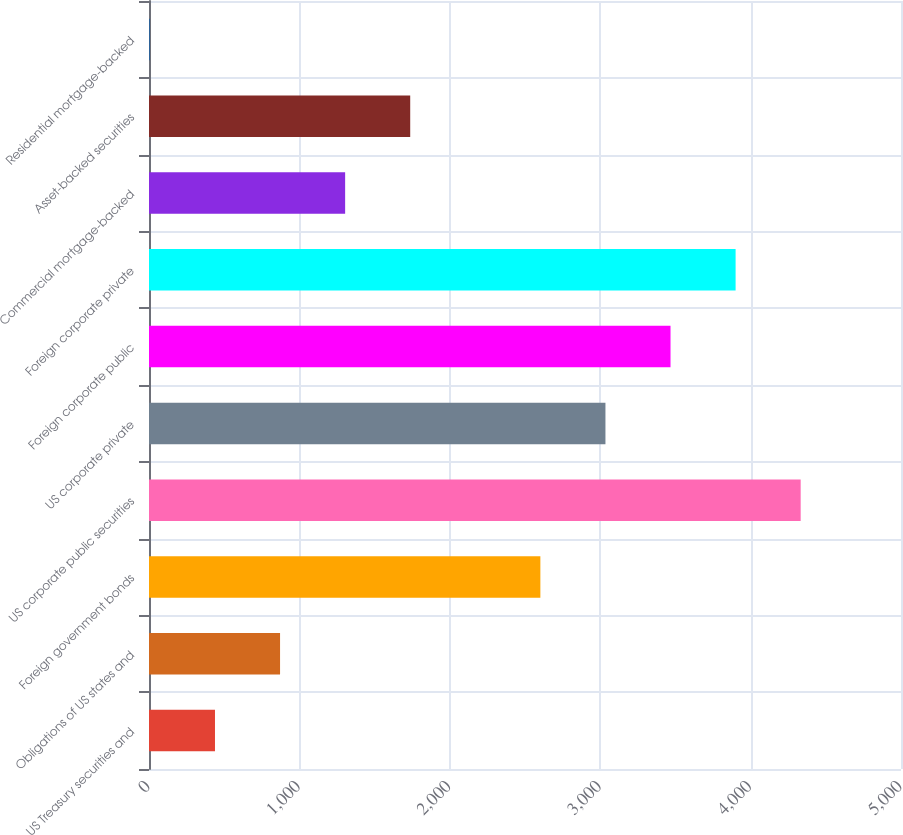<chart> <loc_0><loc_0><loc_500><loc_500><bar_chart><fcel>US Treasury securities and<fcel>Obligations of US states and<fcel>Foreign government bonds<fcel>US corporate public securities<fcel>US corporate private<fcel>Foreign corporate public<fcel>Foreign corporate private<fcel>Commercial mortgage-backed<fcel>Asset-backed securities<fcel>Residential mortgage-backed<nl><fcel>438.7<fcel>871.4<fcel>2602.2<fcel>4333<fcel>3034.9<fcel>3467.6<fcel>3900.3<fcel>1304.1<fcel>1736.8<fcel>6<nl></chart> 